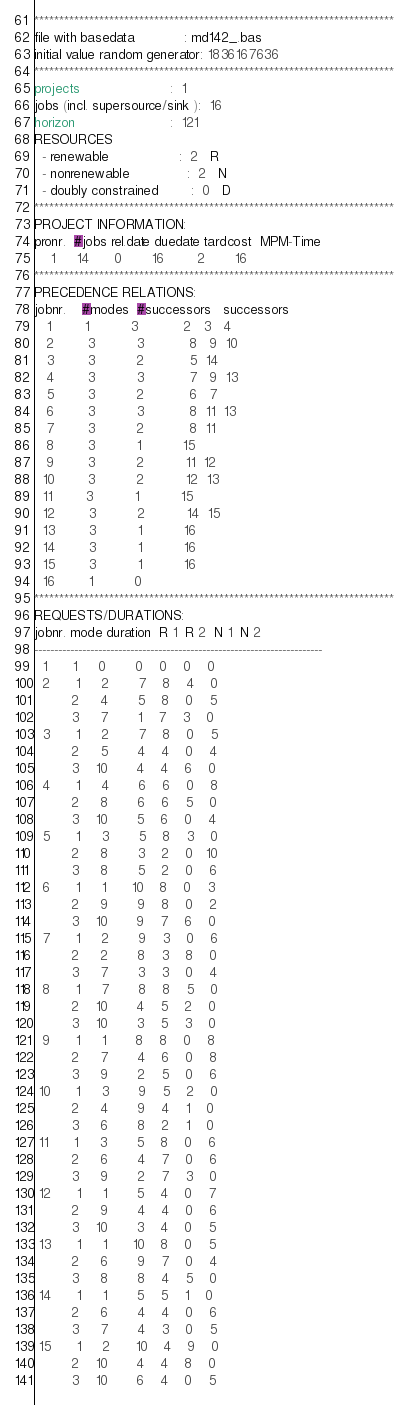Convert code to text. <code><loc_0><loc_0><loc_500><loc_500><_ObjectiveC_>************************************************************************
file with basedata            : md142_.bas
initial value random generator: 1836167636
************************************************************************
projects                      :  1
jobs (incl. supersource/sink ):  16
horizon                       :  121
RESOURCES
  - renewable                 :  2   R
  - nonrenewable              :  2   N
  - doubly constrained        :  0   D
************************************************************************
PROJECT INFORMATION:
pronr.  #jobs rel.date duedate tardcost  MPM-Time
    1     14      0       16        2       16
************************************************************************
PRECEDENCE RELATIONS:
jobnr.    #modes  #successors   successors
   1        1          3           2   3   4
   2        3          3           8   9  10
   3        3          2           5  14
   4        3          3           7   9  13
   5        3          2           6   7
   6        3          3           8  11  13
   7        3          2           8  11
   8        3          1          15
   9        3          2          11  12
  10        3          2          12  13
  11        3          1          15
  12        3          2          14  15
  13        3          1          16
  14        3          1          16
  15        3          1          16
  16        1          0        
************************************************************************
REQUESTS/DURATIONS:
jobnr. mode duration  R 1  R 2  N 1  N 2
------------------------------------------------------------------------
  1      1     0       0    0    0    0
  2      1     2       7    8    4    0
         2     4       5    8    0    5
         3     7       1    7    3    0
  3      1     2       7    8    0    5
         2     5       4    4    0    4
         3    10       4    4    6    0
  4      1     4       6    6    0    8
         2     8       6    6    5    0
         3    10       5    6    0    4
  5      1     3       5    8    3    0
         2     8       3    2    0   10
         3     8       5    2    0    6
  6      1     1      10    8    0    3
         2     9       9    8    0    2
         3    10       9    7    6    0
  7      1     2       9    3    0    6
         2     2       8    3    8    0
         3     7       3    3    0    4
  8      1     7       8    8    5    0
         2    10       4    5    2    0
         3    10       3    5    3    0
  9      1     1       8    8    0    8
         2     7       4    6    0    8
         3     9       2    5    0    6
 10      1     3       9    5    2    0
         2     4       9    4    1    0
         3     6       8    2    1    0
 11      1     3       5    8    0    6
         2     6       4    7    0    6
         3     9       2    7    3    0
 12      1     1       5    4    0    7
         2     9       4    4    0    6
         3    10       3    4    0    5
 13      1     1      10    8    0    5
         2     6       9    7    0    4
         3     8       8    4    5    0
 14      1     1       5    5    1    0
         2     6       4    4    0    6
         3     7       4    3    0    5
 15      1     2      10    4    9    0
         2    10       4    4    8    0
         3    10       6    4    0    5</code> 